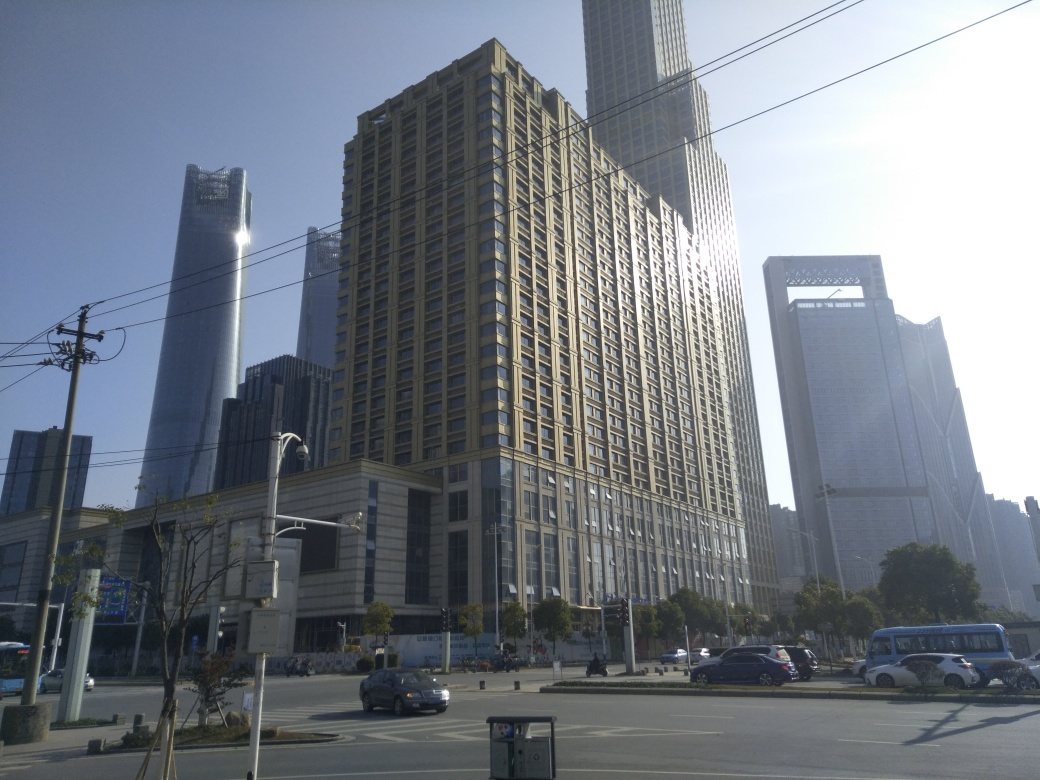Are there any features in the image that suggest a particular climate or part of the world? The image shows no explicit features that strongly indicate a specific climate, but the clear sky and the presence of what appear to be air conditioning units on some buildings could suggest a warm or temperate climate commonly found in many urban cities around the world. 